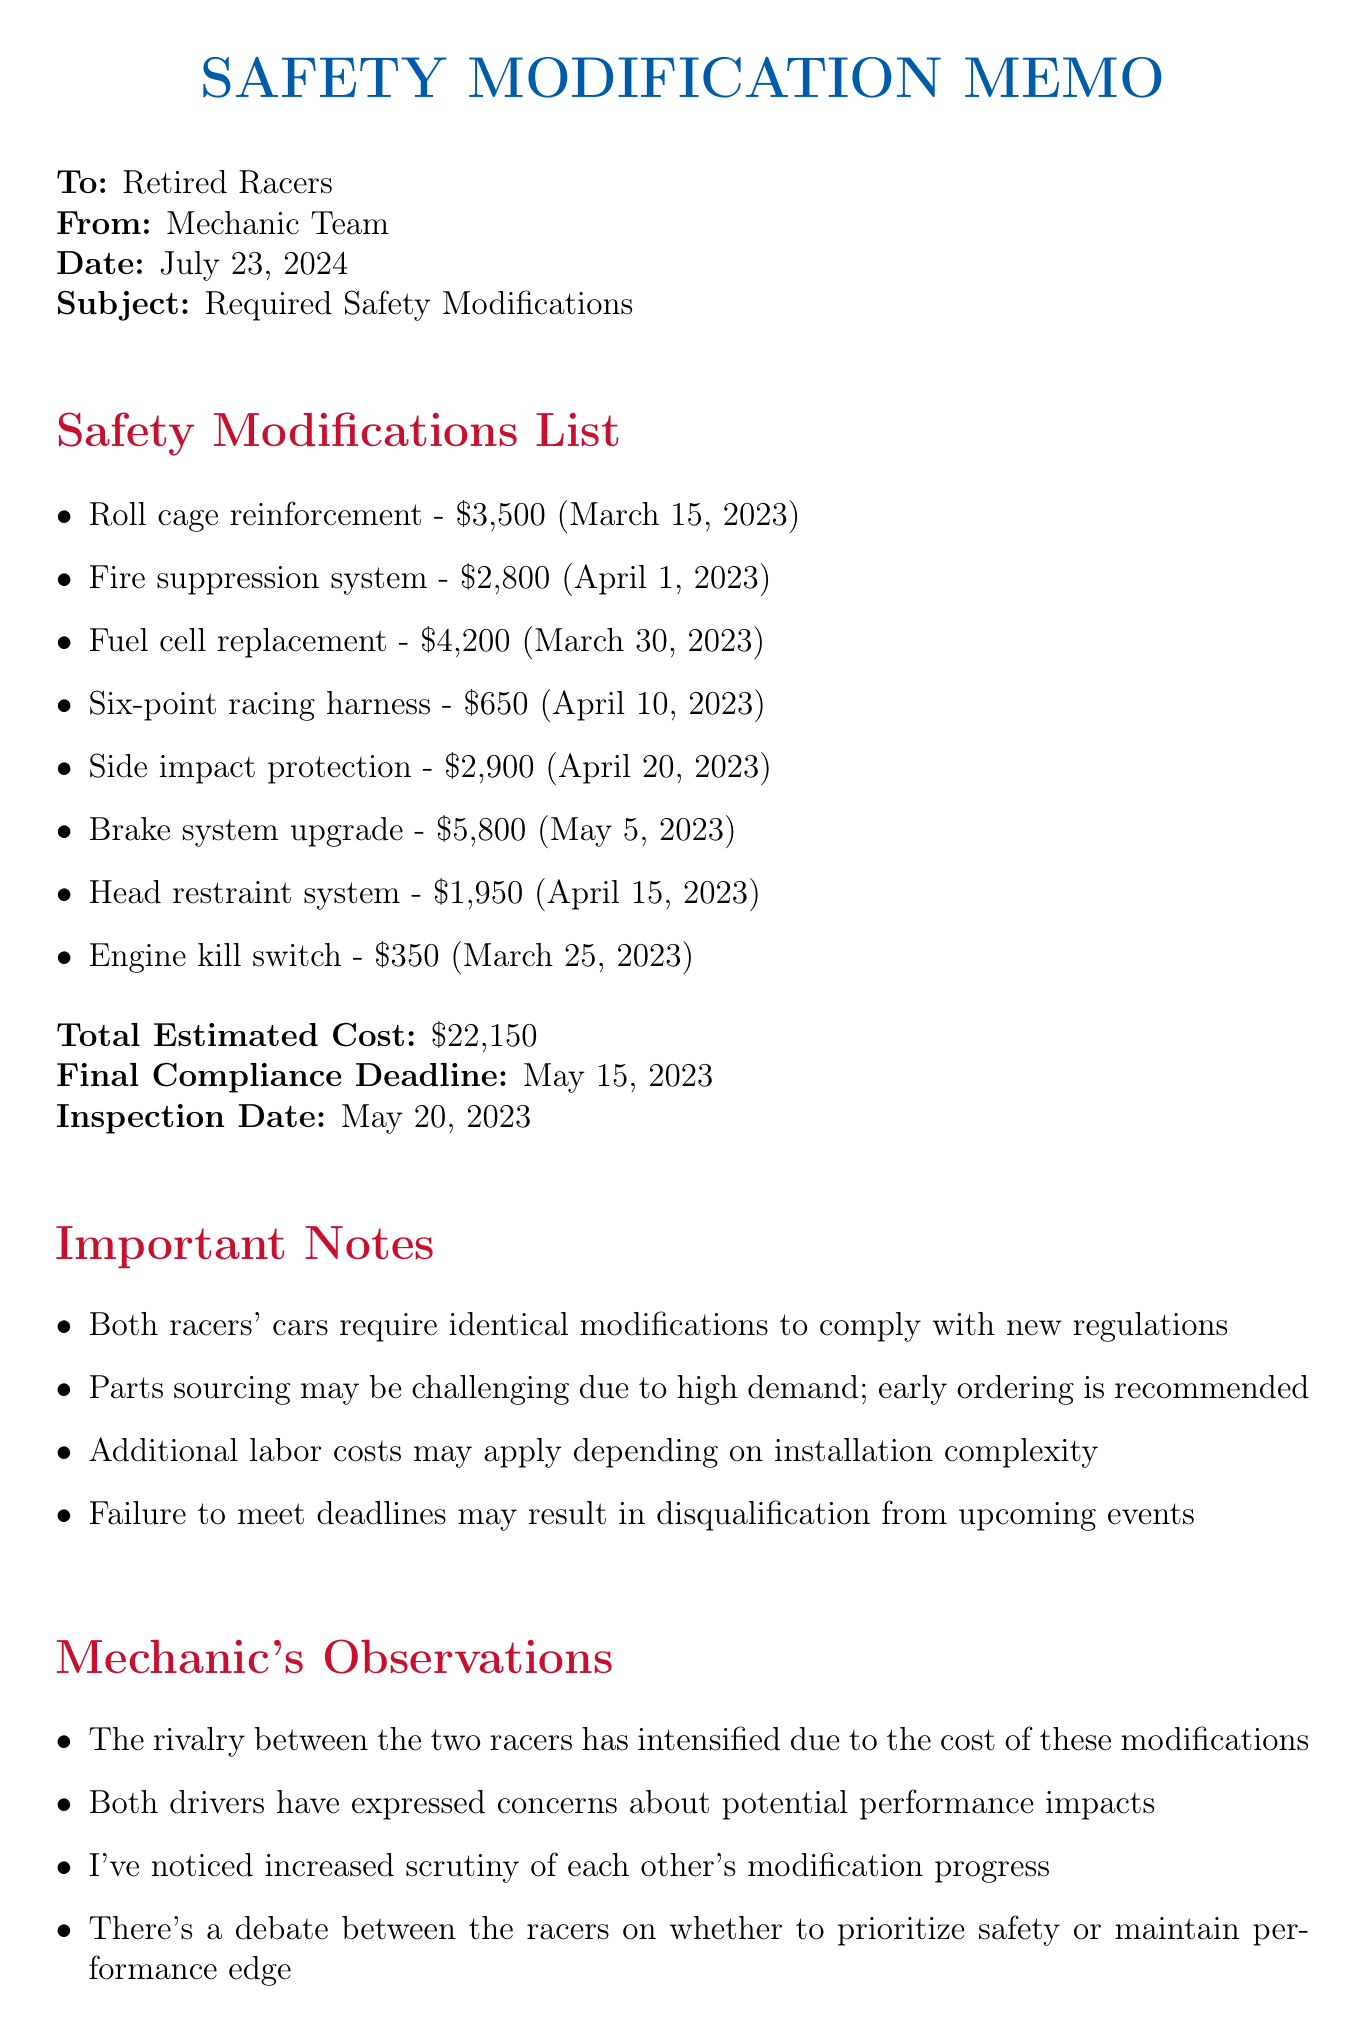What is the total estimated cost of modifications? The total estimated cost is clearly stated in the memo as $22,150.
Answer: $22,150 When is the final compliance deadline? The final compliance deadline is mentioned in the document, which is May 15, 2023.
Answer: May 15, 2023 Which item has the highest cost estimate? By reviewing the listed modifications, the brake system upgrade is identified as the highest cost at $5,800.
Answer: $5,800 What type of racing harness is required? The document specifies that a Sabelt 6-point HANS compatible racing harness is needed.
Answer: Sabelt 6-point HANS compatible racing harness What are the potential consequences of failing to meet deadlines? The memo notes that failing to meet deadlines may result in disqualification from upcoming events, indicating serious consequences.
Answer: Disqualification from upcoming events How many safety modifications are required in total? Counting the items listed in the safety modifications section, there are eight required modifications in total.
Answer: Eight What is the inspection date? The memo states that the inspection date is May 20, 2023.
Answer: May 20, 2023 What additional concern do both drivers have regarding the modifications? Both drivers have expressed concerns about the potential performance impacts due to the required safety modifications.
Answer: Potential performance impacts 